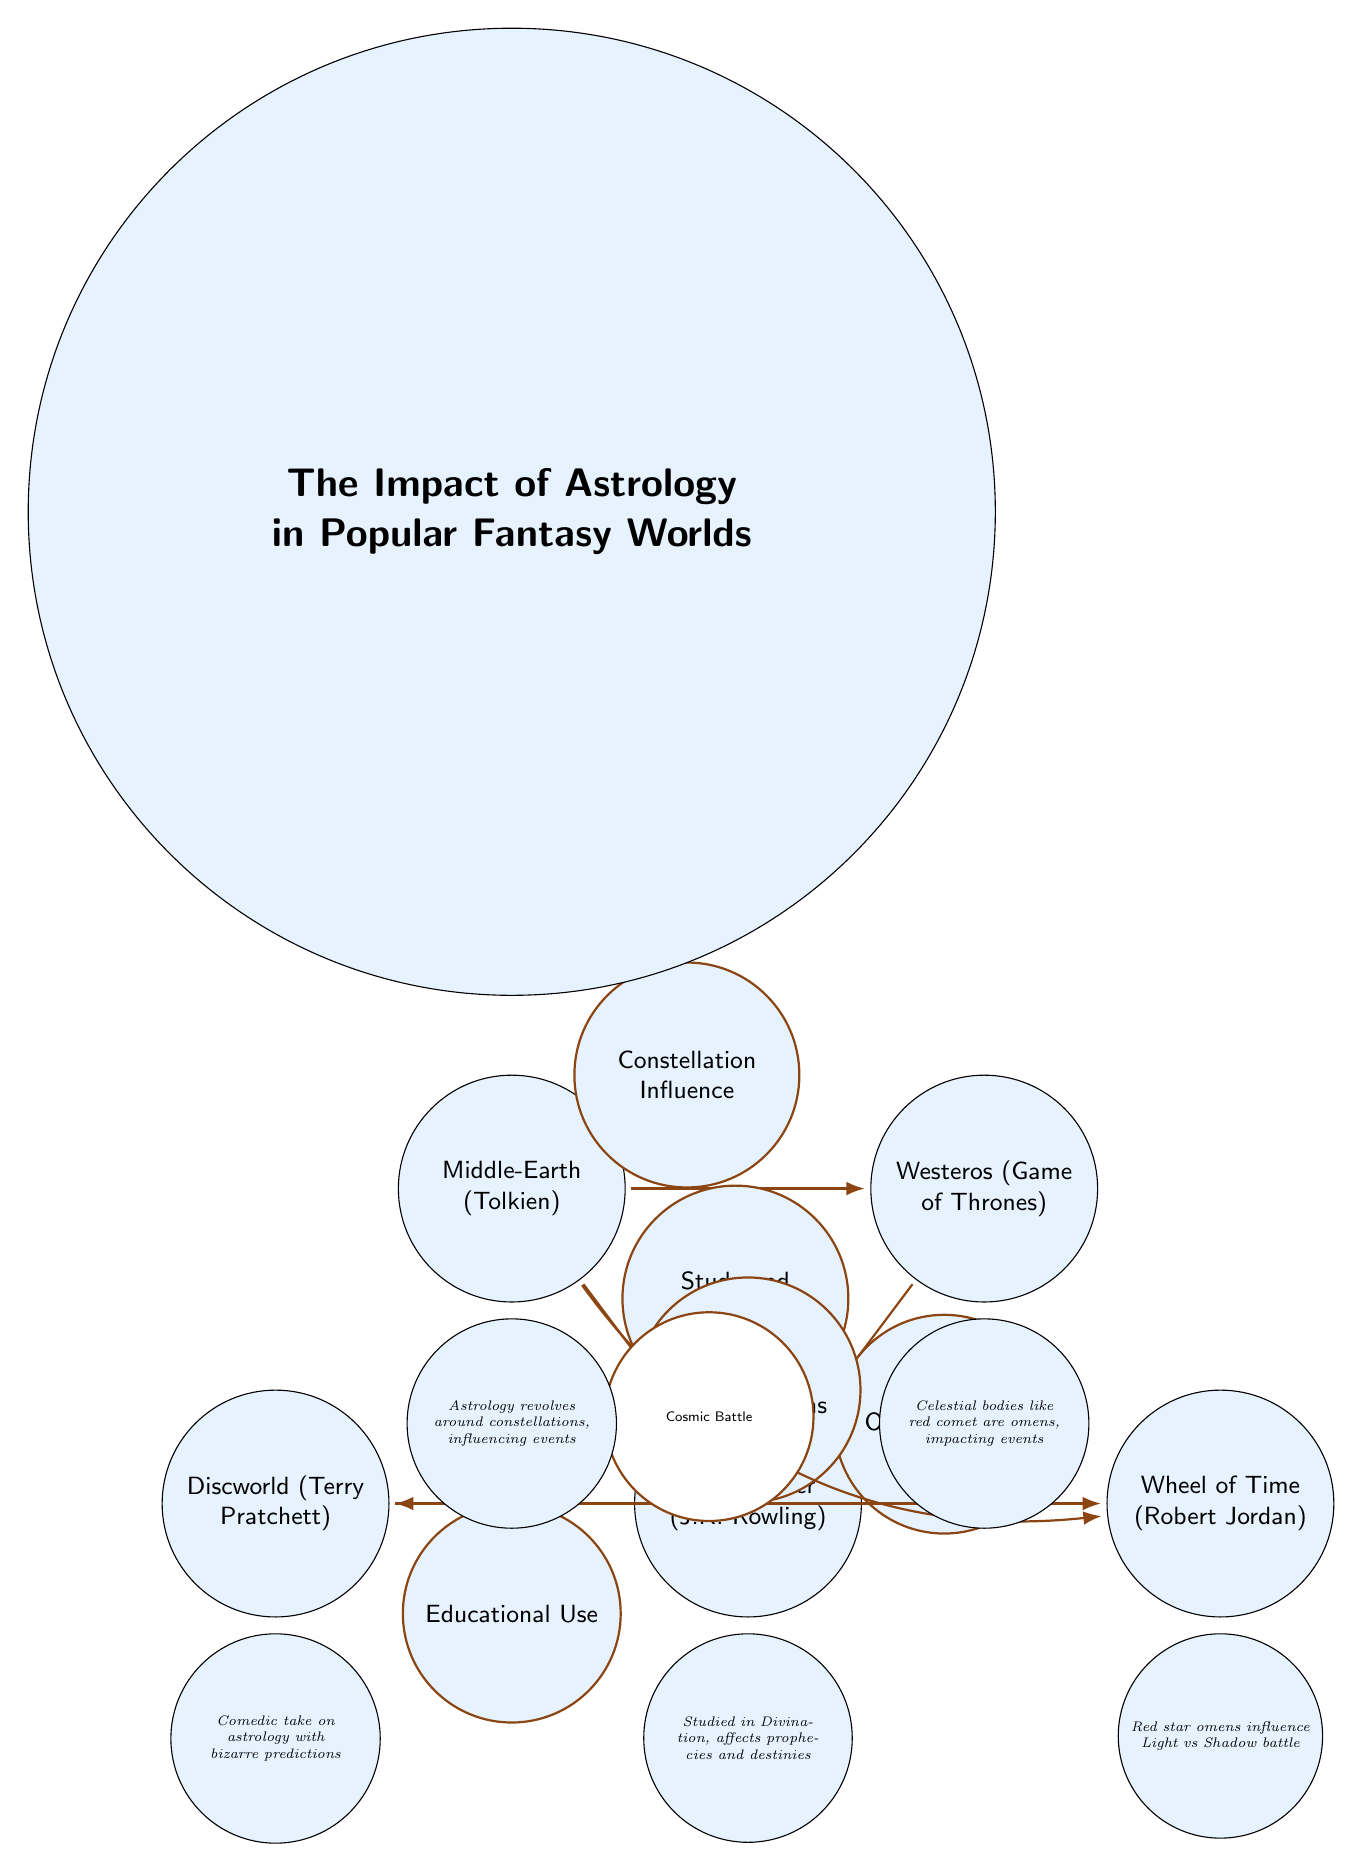What are the two main fantasy worlds connected by "Constellation Influence"? The diagram shows a connection labeled "Constellation Influence" between Middle-Earth and Westeros.
Answer: Middle-Earth, Westeros Which fantasy world is associated with "Study and Prophecy"? In the diagram, the connection labeled "Study and Prophecy" originates from Middle-Earth and points to Harry Potter.
Answer: Harry Potter How many nodes are present in the diagram? The diagram contains five distinct nodes, representing different fantasy worlds.
Answer: 5 What influence does astrology have in Discworld? The diagram indicates that astrology in Discworld is characterized by "Humor vs Serious Omens," highlighting the comedic take on predictions.
Answer: Humor vs Serious Omens What type of influence does Westeros demonstrate toward Harry Potter? The edge labeled "Ominous Signs" shows that Westeros has a direct influence on Harry Potter's storyline regarding astrology.
Answer: Ominous Signs Which fantasy world uses astrology for education? The connection labeled "Educational Use" specifies that Harry Potter incorporates astrology in educational contexts.
Answer: Harry Potter How does astrology impact the battle in Wheel of Time? The diagram notes that a "Red star omens influence Light vs Shadow battle," indicating that astrology plays a pivotal role in the conflict.
Answer: Red star omens What is the relationship between Middle-Earth and Wheel of Time? The diagram shows a curved edge connecting Middle-Earth to Wheel of Time, indicating a cosmic battle influence.
Answer: Cosmic Battle How does the diagram depict the role of constellations in Middle-Earth? The node description states that astrology in Middle-Earth revolves around constellations, showing their influence on events.
Answer: Influencing events 